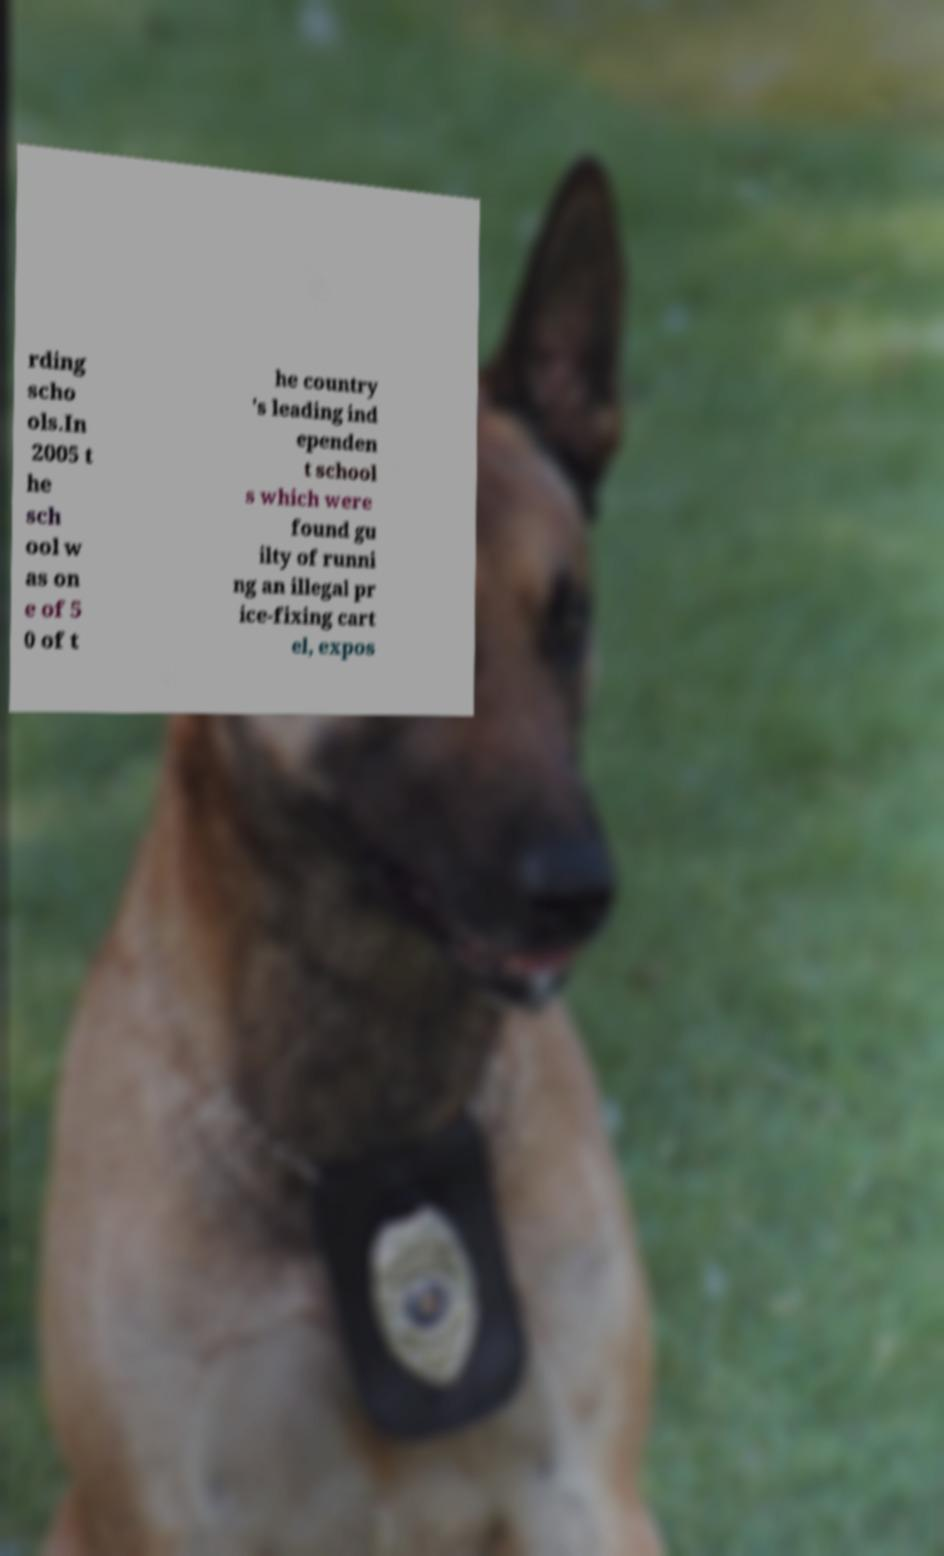Please read and relay the text visible in this image. What does it say? rding scho ols.In 2005 t he sch ool w as on e of 5 0 of t he country 's leading ind ependen t school s which were found gu ilty of runni ng an illegal pr ice-fixing cart el, expos 